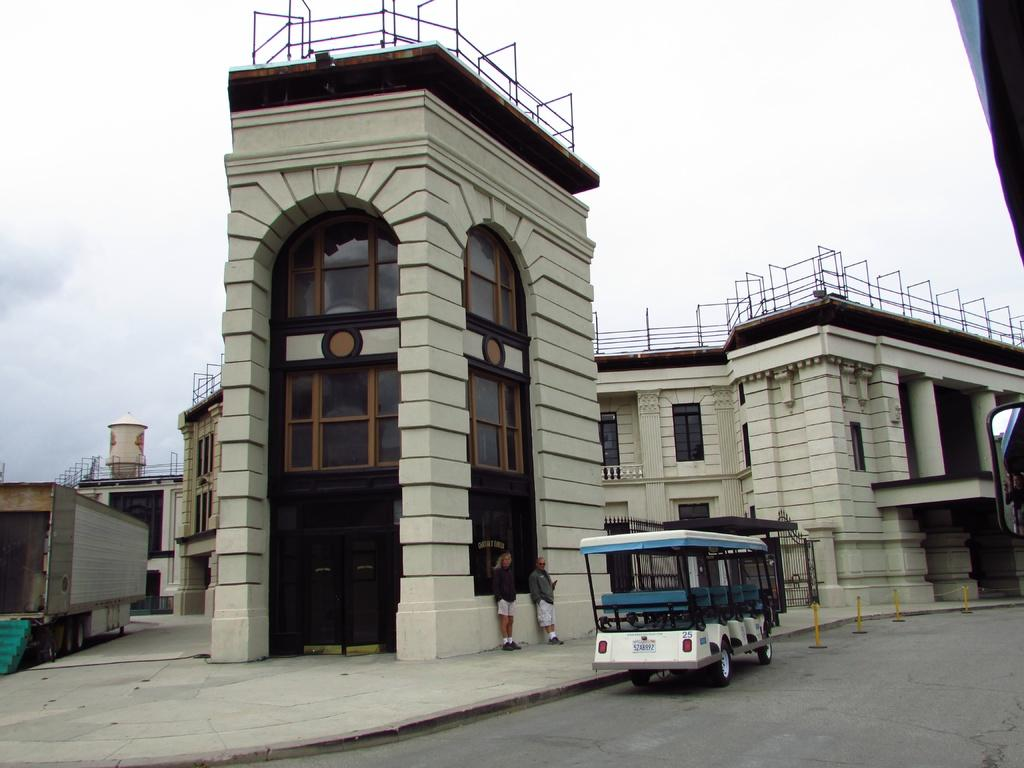What is the main subject in the center of the image? There is a vehicle in the center of the image. Where is the vehicle located? The vehicle is on the road. What can be seen in the background of the image? There are buildings in the background of the image. Are there any people visible in the image? Yes, there are persons standing in the image. How would you describe the weather based on the image? The sky is cloudy in the image. How many cattle can be seen grazing near the rod in the image? There are no cattle or rods present in the image. What type of basin is visible in the image? There is no basin present in the image. 